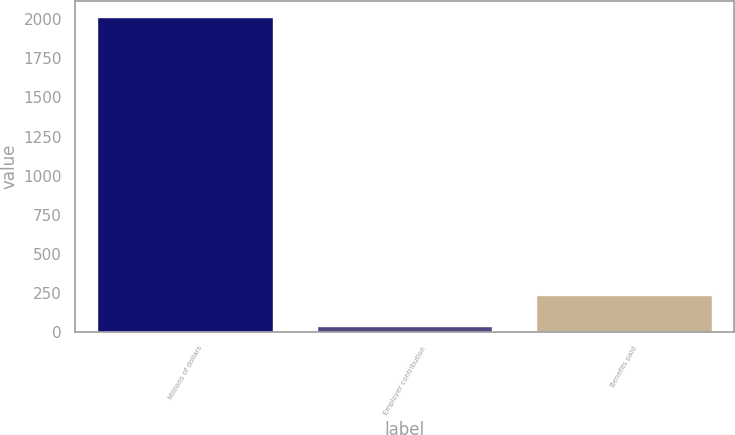<chart> <loc_0><loc_0><loc_500><loc_500><bar_chart><fcel>Millions of dollars<fcel>Employer contribution<fcel>Benefits paid<nl><fcel>2018<fcel>36<fcel>234.2<nl></chart> 